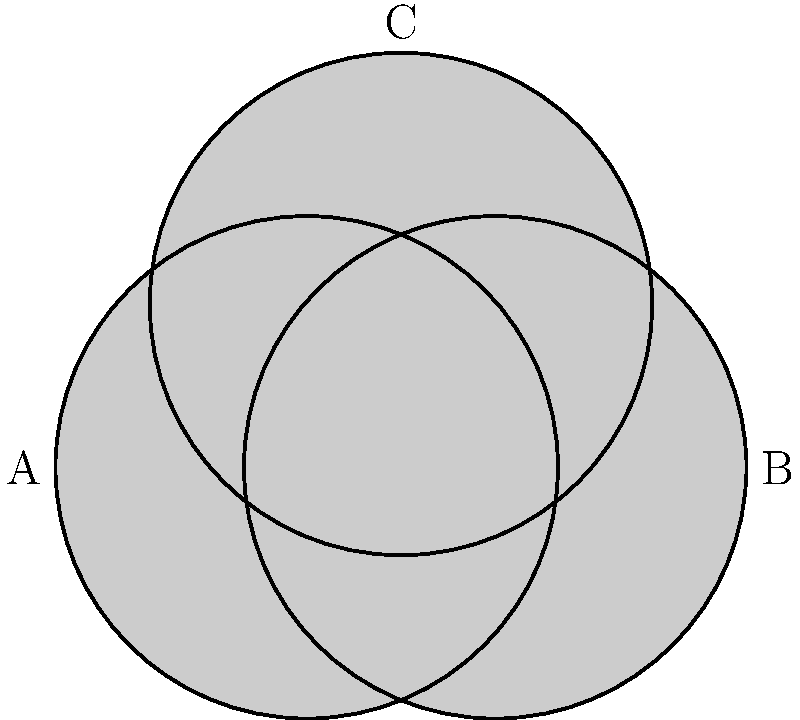In a dark, eerie composition, three shadowy circles overlap to create an unsettling Venn diagram-like arrangement. Each circle has a radius of 2 units. Circles A and B have their centers 1.5 units apart on a horizontal line. Circle C's center is positioned 1.3 units above the midpoint between the centers of A and B. Calculate the total area of the negative space (the area not covered by any circle) in this nightmarish arrangement. Round your answer to two decimal places. To find the area of the negative space, we need to:

1. Calculate the total area of the bounding rectangle:
   Rectangle area = $4 \times 4.3 = 17.2$ square units

2. Calculate the area of a single circle:
   Circle area = $\pi r^2 = \pi \times 2^2 = 4\pi$ square units

3. Calculate the total area of all three circles:
   Total circle area = $3 \times 4\pi = 12\pi$ square units

4. Calculate the areas of overlap between circles:
   a) For A and B: $d = 1.5$, use the formula:
      $A_{overlap} = 2r^2 \arccos(\frac{d}{2r}) - d\sqrt{r^2 - \frac{d^2}{4}}$
      $A_{AB} = 8 \arccos(\frac{3}{8}) - 1.5\sqrt{4 - \frac{9}{16}} \approx 4.47$ sq units

   b) For A and C, and B and C: $d = \sqrt{1.3^2 + 0.75^2} \approx 1.5$
      $A_{AC} = A_{BC} \approx 4.47$ sq units

5. Calculate the area of the triple overlap using numerical methods:
   $A_{ABC} \approx 1.15$ sq units

6. Calculate the total area covered by the circles:
   $A_{covered} = 12\pi - (4.47 + 4.47 + 4.47) + 1.15 = 12\pi - 12.26$ sq units

7. Calculate the negative space:
   $A_{negative} = 17.2 - (12\pi - 12.26) \approx 4.46$ sq units
Answer: 4.46 square units 